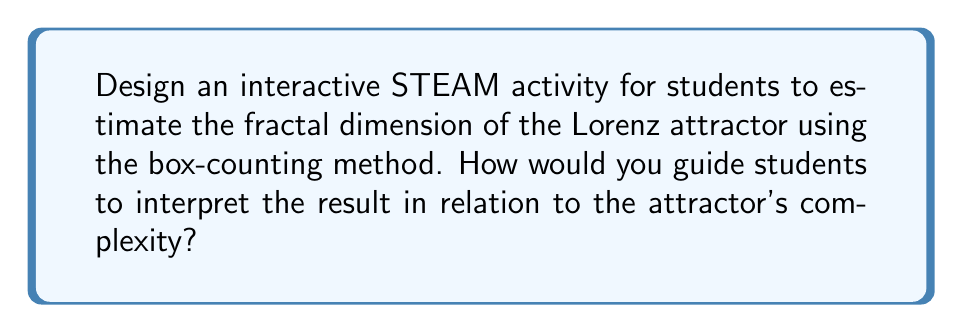Could you help me with this problem? To create an interactive STEAM activity for estimating the fractal dimension of the Lorenz attractor using the box-counting method, follow these steps:

1. Introduce the Lorenz attractor:
   - Explain that the Lorenz attractor is a chaotic system represented by three differential equations:
     $$\frac{dx}{dt} = \sigma(y - x)$$
     $$\frac{dy}{dt} = x(\rho - z) - y$$
     $$\frac{dz}{dt} = xy - \beta z$$
   - Use software like Python or MATLAB to generate and visualize the Lorenz attractor.

2. Explain the box-counting method:
   - Cover the attractor with a grid of boxes with side length $\epsilon$.
   - Count the number of boxes $N(\epsilon)$ that contain part of the attractor.
   - Repeat for different box sizes.

3. Guide students to estimate the fractal dimension:
   - Plot $\log(N(\epsilon))$ against $\log(1/\epsilon)$.
   - The slope of this line approximates the fractal dimension $D$.
   - Use the formula: $D \approx -\frac{\log(N(\epsilon_2)) - \log(N(\epsilon_1))}{\log(\epsilon_2) - \log(\epsilon_1)}$

4. Implement the activity:
   - Provide students with pre-generated Lorenz attractor images at different scales.
   - Have them count boxes manually for larger scales and use image processing tools for smaller scales.
   - Create a spreadsheet to record data and calculate the dimension.

5. Interpret the results:
   - The Lorenz attractor's fractal dimension is approximately 2.06.
   - Discuss how this non-integer dimension relates to the attractor's complexity:
     - It's between a 2D surface and a 3D volume, indicating intricate structure.
     - The fractional part (0.06) represents the attractor's self-similarity and infinite detail.

6. Extend the activity:
   - Compare the Lorenz attractor's dimension to other fractals (e.g., Koch snowflake, Sierpinski triangle).
   - Discuss how fractal dimension relates to real-world phenomena in nature and engineering.

This activity integrates Science (chaos theory), Technology (software visualization), Engineering (data analysis), Arts (visual representation), and Mathematics (dimensional analysis), making it an ideal STEAM project.
Answer: Fractal dimension ≈ 2.06, indicating complex structure between 2D and 3D 